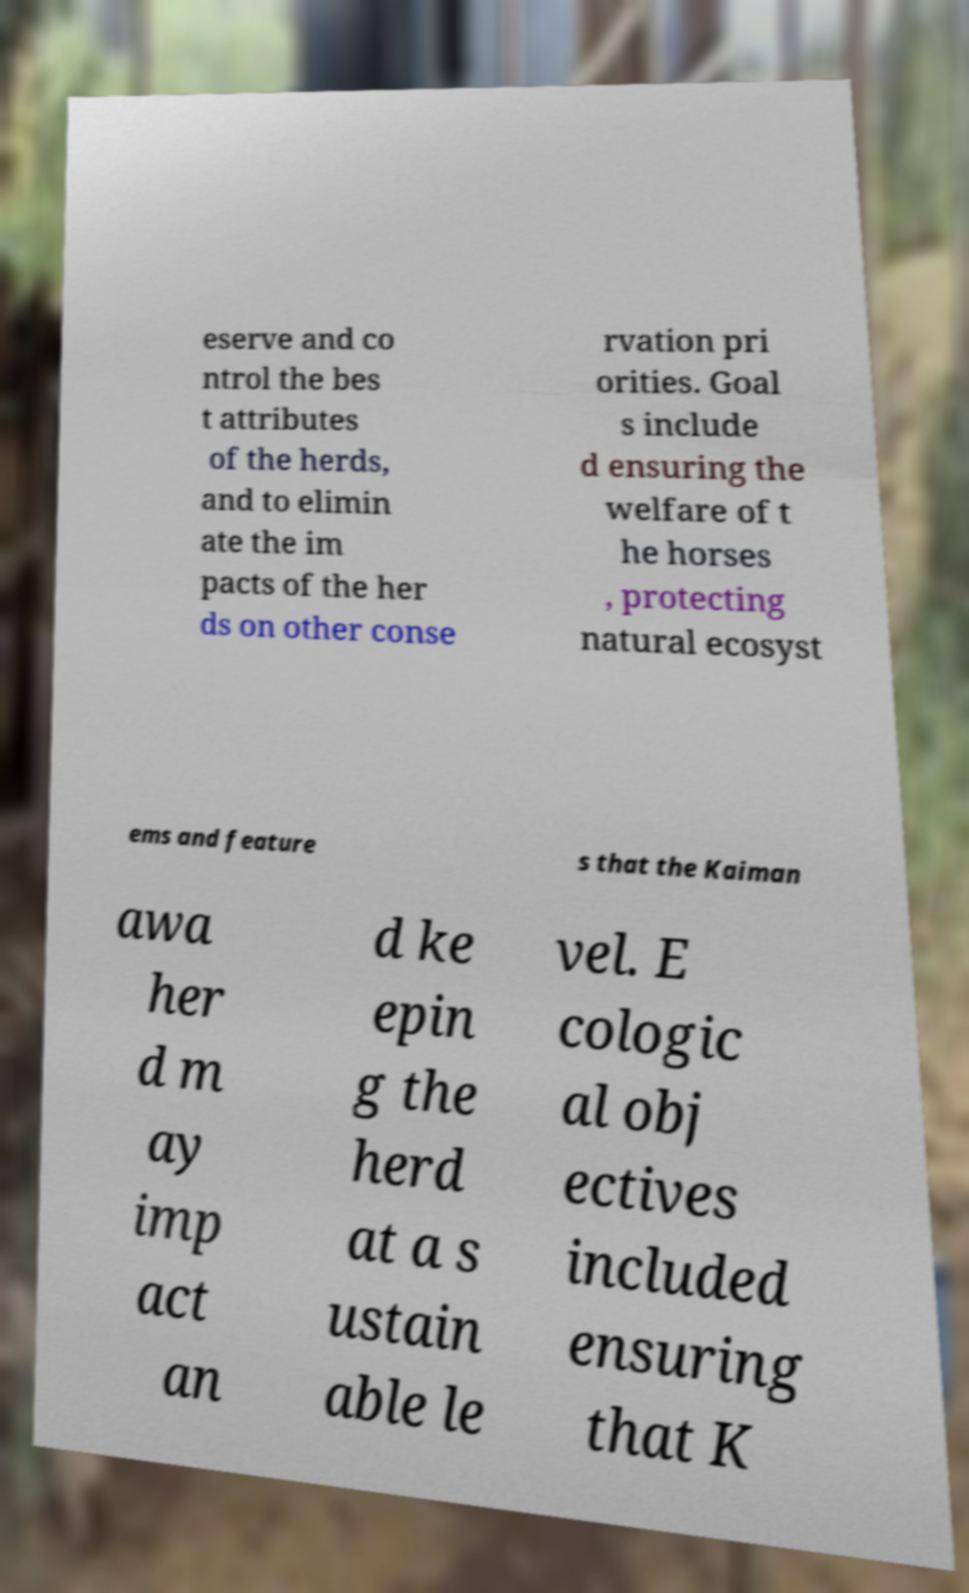Please read and relay the text visible in this image. What does it say? eserve and co ntrol the bes t attributes of the herds, and to elimin ate the im pacts of the her ds on other conse rvation pri orities. Goal s include d ensuring the welfare of t he horses , protecting natural ecosyst ems and feature s that the Kaiman awa her d m ay imp act an d ke epin g the herd at a s ustain able le vel. E cologic al obj ectives included ensuring that K 